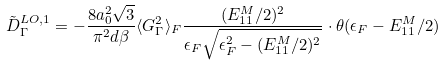<formula> <loc_0><loc_0><loc_500><loc_500>\tilde { D } _ { \Gamma } ^ { L O , 1 } = - \frac { 8 a _ { 0 } ^ { 2 } \sqrt { 3 } } { \pi ^ { 2 } d \beta } \langle G _ { \Gamma } ^ { 2 } \rangle _ { F } \frac { ( E _ { 1 1 } ^ { M } / 2 ) ^ { 2 } } { \epsilon _ { F } \sqrt { \epsilon _ { F } ^ { 2 } - ( E _ { 1 1 } ^ { M } / 2 ) ^ { 2 } } } \cdot \theta ( \epsilon _ { F } - E _ { 1 1 } ^ { M } / 2 )</formula> 